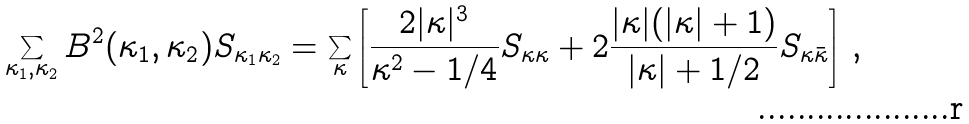<formula> <loc_0><loc_0><loc_500><loc_500>\sum _ { \kappa _ { 1 } , \kappa _ { 2 } } B ^ { 2 } ( \kappa _ { 1 } , \kappa _ { 2 } ) S _ { \kappa _ { 1 } \kappa _ { 2 } } = \sum _ { \kappa } \left [ \frac { 2 | \kappa | ^ { 3 } } { \kappa ^ { 2 } - 1 / 4 } S _ { \kappa \kappa } + 2 \frac { | \kappa | ( | \kappa | + 1 ) } { | \kappa | + 1 / 2 } S _ { \kappa \bar { \kappa } } \right ] \, ,</formula> 